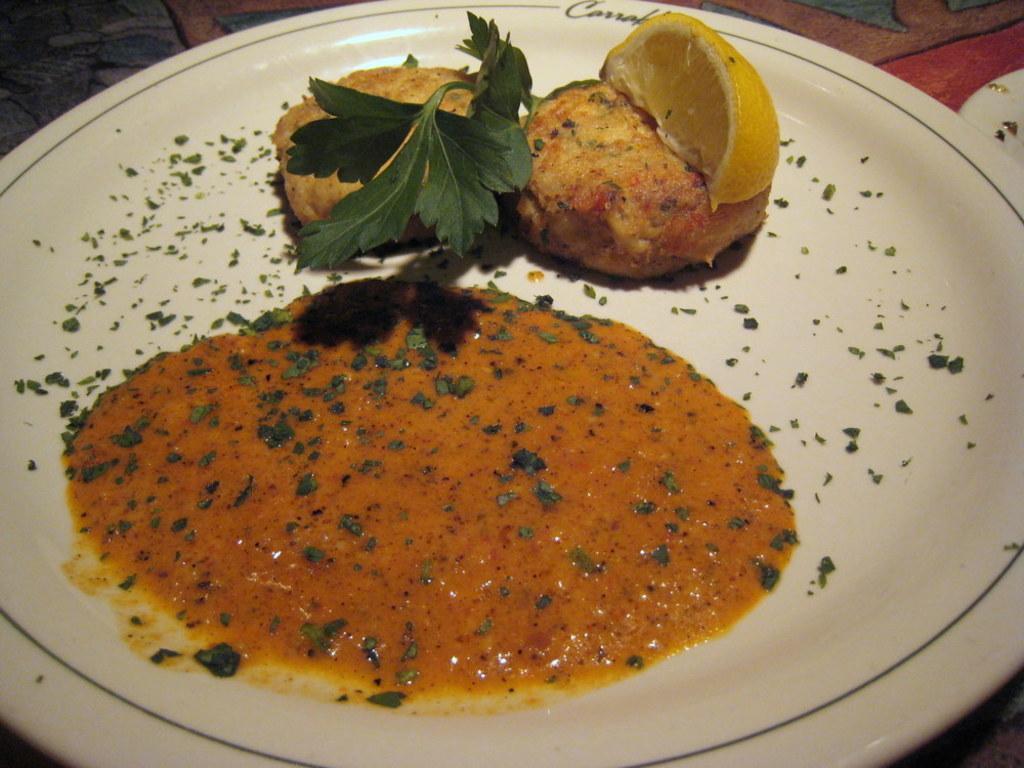Please provide a concise description of this image. In this picture I can see the white color plate and in it I can see food which is of brown, yellow and red color and I see coriander leaves. 